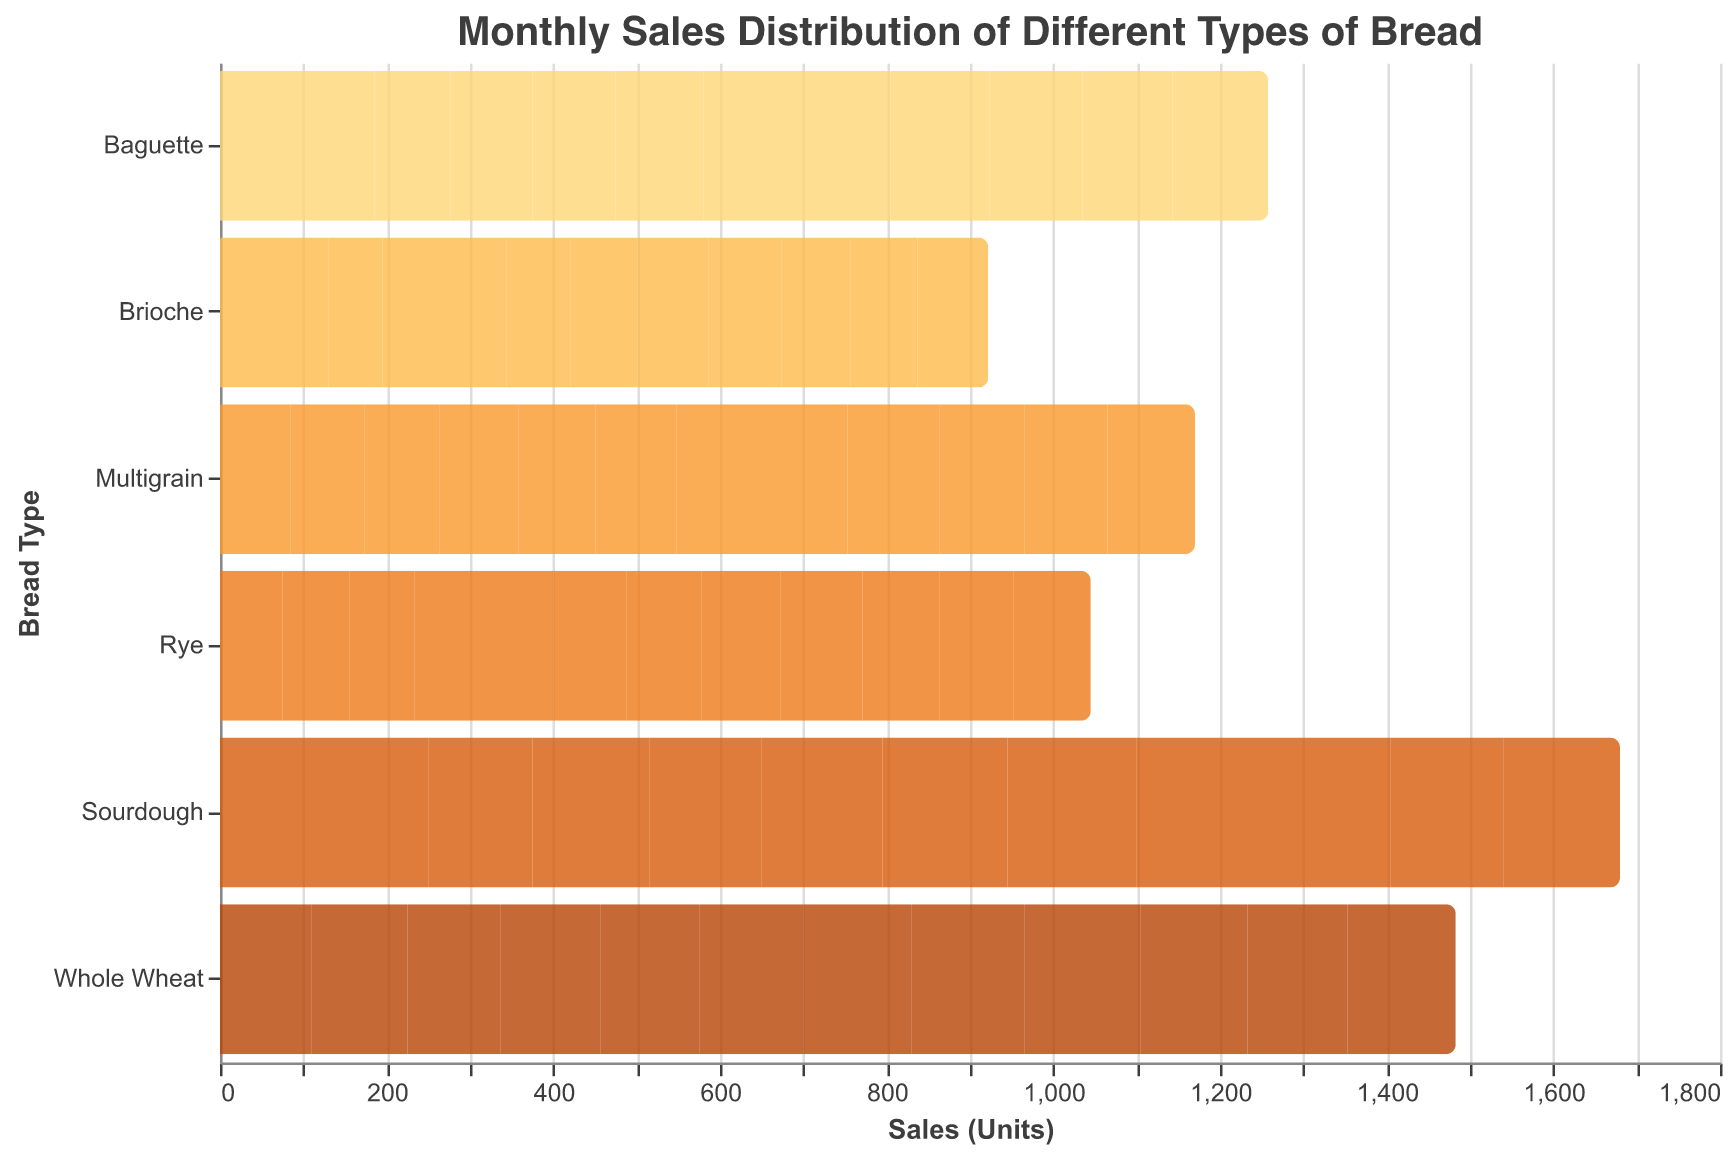How many different types of bread are displayed in the figure? The figure shows the monthly sales for different types of bread. By counting the unique types listed on the y-axis, we can see there are 6 types.
Answer: 6 Which type of bread was sold the most in August? Observing the sales units in August for each type of bread, Sourdough has the highest bar with 155 units sold.
Answer: Sourdough What is the total sales for Rye bread in the first quarter (January, February, and March)? Adding the sales units of Rye bread for January (75), February (80), and March (78) results in 75 + 80 + 78 = 233.
Answer: 233 Compare the sales of Whole Wheat and Multigrain bread in December. Which one is higher? By looking at the sales units in December, Whole Wheat has 130 whereas Multigrain has 105. Whole Wheat has higher sales.
Answer: Whole Wheat What is the average monthly sales for Baguette bread? To find the average, sum the sales for Baguette from January to December: 90 + 95 + 92 + 98 + 100 + 105 + 110 + 115 + 118 + 112 + 108 + 115 = 1248. Then divide by 12: 1248 / 12 = 104.
Answer: 104 Which month recorded the highest sales for Sourdough bread? Checking the sales bars for Sourdough in each month, the highest sales is in September with 160 units.
Answer: September What is the difference in sales units between Brioche and Multigrain bread in July? In July, Brioche has 80 units and Multigrain has 100 units. The difference is 100 - 80 = 20.
Answer: 20 What is the overall trend for the sales of Sourdough bread from January to December? Observing the sales for Sourdough bread from January to December, the sales generally increase, peaking in September, and then slightly decrease towards the end of the year.
Answer: Increasing trend with peak in September Which type of bread consistently had the lowest sales across all months? Each month, Brioche has the lowest sales compared to other types, indicating it consistently had the lowest sales.
Answer: Brioche How do the sales in June compare between Whole Wheat and Rye bread? In June, Whole Wheat sales are 125 units and Rye sales are 88 units. Whole Wheat sales are higher.
Answer: Whole Wheat 